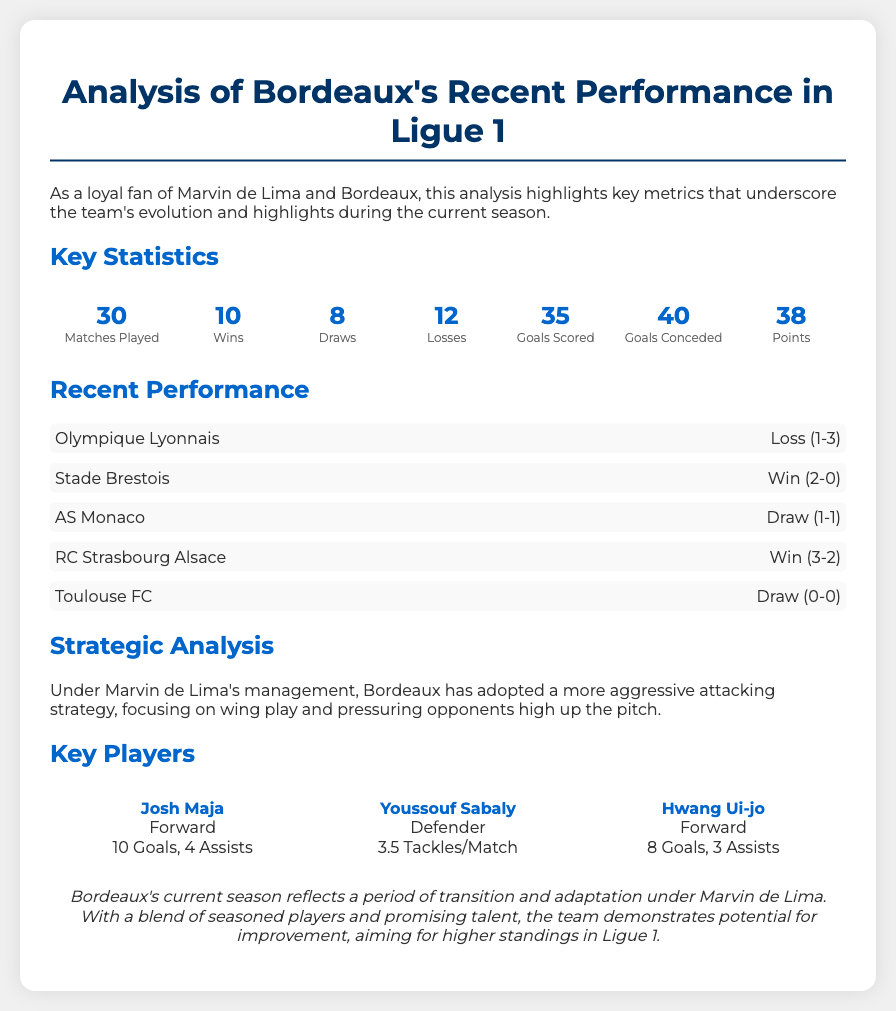What is the total number of matches played by Bordeaux? The total number of matches played is listed in the Key Statistics section, which states the number of matches played is 30.
Answer: 30 How many goals has Bordeaux scored this season? The number of goals scored is provided in the Key Statistics section, which shows that Bordeaux has scored 35 goals.
Answer: 35 Who scored the most goals for Bordeaux? The Key Players section indicates that Josh Maja, with 10 goals, has the highest goals scored.
Answer: Josh Maja What was Bordeaux's last match outcome? The recent performance section lists the last match against Olympique Lyonnais, which was a loss.
Answer: Loss What is the total points Bordeaux has earned? The total points are found in the Key Statistics section, which indicates Bordeaux has earned 38 points.
Answer: 38 How many draws has Bordeaux recorded in the season? The number of draws is detailed in the Key Statistics section, which states there have been 8 draws.
Answer: 8 What is Bordeaux's goals conceded this season? The number of goals conceded is shown in the Key Statistics section, which states that 40 goals have been conceded.
Answer: 40 What tactical approach has Bordeaux adopted under Marvin de Lima? The Strategic Analysis section discusses the tactical approach, indicating a more aggressive attacking strategy is used.
Answer: Aggressive attacking strategy Who is the defender mentioned as key for Bordeaux? The Key Players section lists Youssouf Sabaly as a key defender for Bordeaux.
Answer: Youssouf Sabaly 